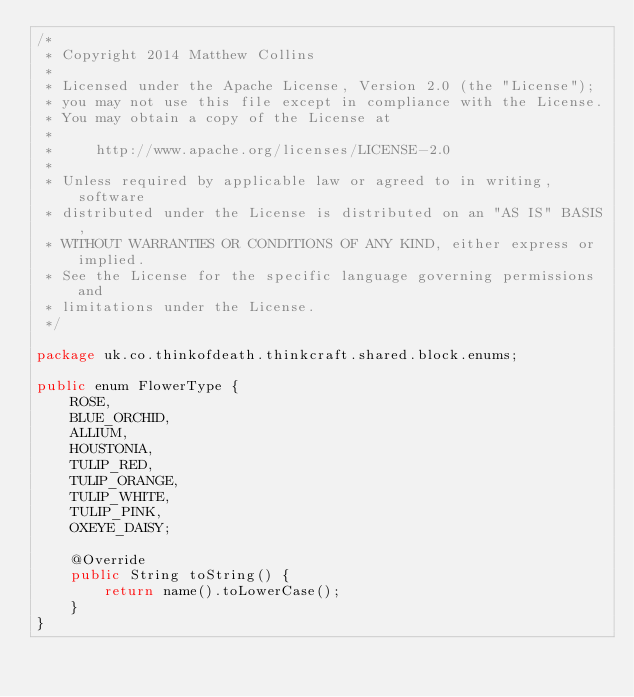Convert code to text. <code><loc_0><loc_0><loc_500><loc_500><_Java_>/*
 * Copyright 2014 Matthew Collins
 *
 * Licensed under the Apache License, Version 2.0 (the "License");
 * you may not use this file except in compliance with the License.
 * You may obtain a copy of the License at
 *
 *     http://www.apache.org/licenses/LICENSE-2.0
 *
 * Unless required by applicable law or agreed to in writing, software
 * distributed under the License is distributed on an "AS IS" BASIS,
 * WITHOUT WARRANTIES OR CONDITIONS OF ANY KIND, either express or implied.
 * See the License for the specific language governing permissions and
 * limitations under the License.
 */

package uk.co.thinkofdeath.thinkcraft.shared.block.enums;

public enum FlowerType {
    ROSE,
    BLUE_ORCHID,
    ALLIUM,
    HOUSTONIA,
    TULIP_RED,
    TULIP_ORANGE,
    TULIP_WHITE,
    TULIP_PINK,
    OXEYE_DAISY;

    @Override
    public String toString() {
        return name().toLowerCase();
    }
}
</code> 